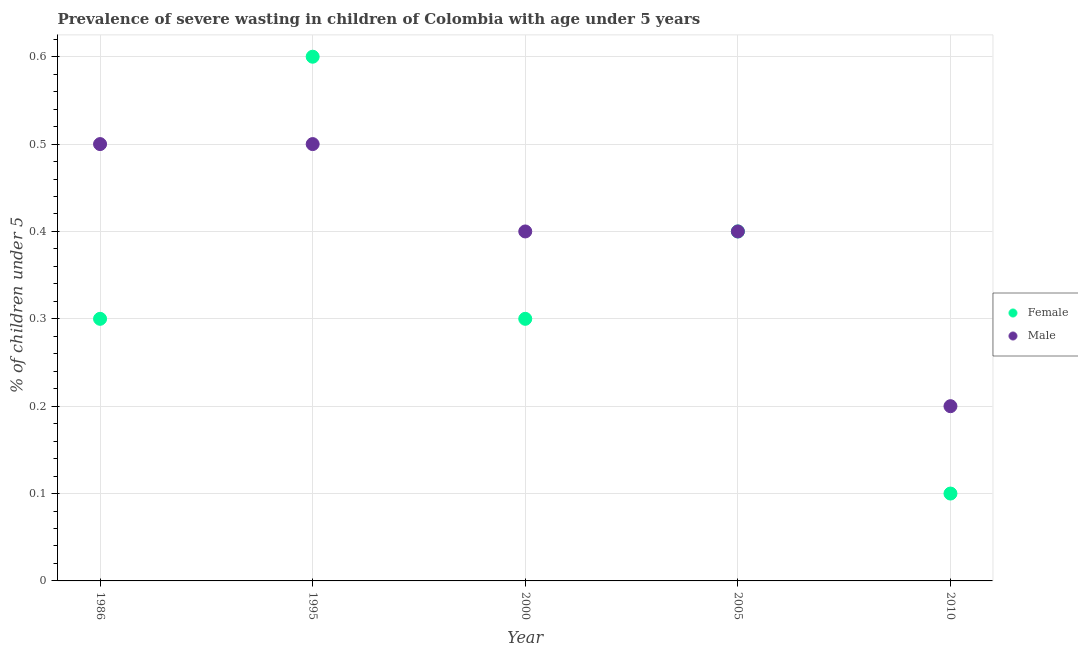How many different coloured dotlines are there?
Give a very brief answer. 2. Across all years, what is the maximum percentage of undernourished female children?
Your answer should be very brief. 0.6. Across all years, what is the minimum percentage of undernourished male children?
Make the answer very short. 0.2. In which year was the percentage of undernourished male children maximum?
Offer a very short reply. 1986. What is the total percentage of undernourished female children in the graph?
Your response must be concise. 1.7. What is the difference between the percentage of undernourished female children in 2000 and that in 2005?
Ensure brevity in your answer.  -0.1. What is the difference between the percentage of undernourished female children in 2010 and the percentage of undernourished male children in 1986?
Ensure brevity in your answer.  -0.4. What is the average percentage of undernourished female children per year?
Keep it short and to the point. 0.34. In the year 2000, what is the difference between the percentage of undernourished male children and percentage of undernourished female children?
Provide a short and direct response. 0.1. What is the difference between the highest and the lowest percentage of undernourished male children?
Keep it short and to the point. 0.3. Is the percentage of undernourished male children strictly greater than the percentage of undernourished female children over the years?
Your answer should be very brief. No. How many years are there in the graph?
Keep it short and to the point. 5. Does the graph contain grids?
Keep it short and to the point. Yes. How are the legend labels stacked?
Your answer should be compact. Vertical. What is the title of the graph?
Offer a very short reply. Prevalence of severe wasting in children of Colombia with age under 5 years. Does "Private consumption" appear as one of the legend labels in the graph?
Give a very brief answer. No. What is the label or title of the Y-axis?
Give a very brief answer.  % of children under 5. What is the  % of children under 5 in Female in 1986?
Ensure brevity in your answer.  0.3. What is the  % of children under 5 in Male in 1986?
Make the answer very short. 0.5. What is the  % of children under 5 in Female in 1995?
Offer a terse response. 0.6. What is the  % of children under 5 in Male in 1995?
Give a very brief answer. 0.5. What is the  % of children under 5 of Female in 2000?
Make the answer very short. 0.3. What is the  % of children under 5 of Male in 2000?
Offer a terse response. 0.4. What is the  % of children under 5 of Female in 2005?
Provide a short and direct response. 0.4. What is the  % of children under 5 in Male in 2005?
Your response must be concise. 0.4. What is the  % of children under 5 of Female in 2010?
Offer a terse response. 0.1. What is the  % of children under 5 in Male in 2010?
Make the answer very short. 0.2. Across all years, what is the maximum  % of children under 5 of Female?
Keep it short and to the point. 0.6. Across all years, what is the minimum  % of children under 5 in Female?
Provide a succinct answer. 0.1. Across all years, what is the minimum  % of children under 5 of Male?
Provide a short and direct response. 0.2. What is the total  % of children under 5 of Female in the graph?
Give a very brief answer. 1.7. What is the difference between the  % of children under 5 in Female in 1986 and that in 1995?
Offer a very short reply. -0.3. What is the difference between the  % of children under 5 in Male in 1986 and that in 2000?
Give a very brief answer. 0.1. What is the difference between the  % of children under 5 in Female in 1986 and that in 2005?
Your answer should be very brief. -0.1. What is the difference between the  % of children under 5 of Female in 1986 and that in 2010?
Your answer should be compact. 0.2. What is the difference between the  % of children under 5 in Male in 1986 and that in 2010?
Provide a short and direct response. 0.3. What is the difference between the  % of children under 5 of Male in 1995 and that in 2000?
Provide a short and direct response. 0.1. What is the difference between the  % of children under 5 in Female in 1995 and that in 2005?
Your answer should be compact. 0.2. What is the difference between the  % of children under 5 in Male in 2000 and that in 2005?
Give a very brief answer. 0. What is the difference between the  % of children under 5 in Female in 2000 and that in 2010?
Your response must be concise. 0.2. What is the difference between the  % of children under 5 of Male in 2000 and that in 2010?
Your answer should be very brief. 0.2. What is the difference between the  % of children under 5 in Female in 2005 and that in 2010?
Keep it short and to the point. 0.3. What is the difference between the  % of children under 5 of Female in 1986 and the  % of children under 5 of Male in 1995?
Your answer should be compact. -0.2. What is the difference between the  % of children under 5 of Female in 1986 and the  % of children under 5 of Male in 2005?
Your answer should be compact. -0.1. What is the average  % of children under 5 of Female per year?
Keep it short and to the point. 0.34. In the year 1995, what is the difference between the  % of children under 5 of Female and  % of children under 5 of Male?
Offer a terse response. 0.1. In the year 2000, what is the difference between the  % of children under 5 of Female and  % of children under 5 of Male?
Give a very brief answer. -0.1. In the year 2005, what is the difference between the  % of children under 5 of Female and  % of children under 5 of Male?
Ensure brevity in your answer.  0. In the year 2010, what is the difference between the  % of children under 5 in Female and  % of children under 5 in Male?
Give a very brief answer. -0.1. What is the ratio of the  % of children under 5 in Male in 1986 to that in 2000?
Give a very brief answer. 1.25. What is the ratio of the  % of children under 5 in Female in 1986 to that in 2005?
Ensure brevity in your answer.  0.75. What is the ratio of the  % of children under 5 of Male in 1986 to that in 2010?
Give a very brief answer. 2.5. What is the ratio of the  % of children under 5 of Male in 1995 to that in 2000?
Offer a very short reply. 1.25. What is the ratio of the  % of children under 5 of Male in 1995 to that in 2005?
Your answer should be very brief. 1.25. What is the ratio of the  % of children under 5 of Male in 1995 to that in 2010?
Provide a short and direct response. 2.5. What is the ratio of the  % of children under 5 of Female in 2000 to that in 2005?
Your answer should be compact. 0.75. What is the ratio of the  % of children under 5 of Male in 2005 to that in 2010?
Offer a terse response. 2. What is the difference between the highest and the lowest  % of children under 5 of Female?
Your answer should be compact. 0.5. What is the difference between the highest and the lowest  % of children under 5 in Male?
Your answer should be compact. 0.3. 